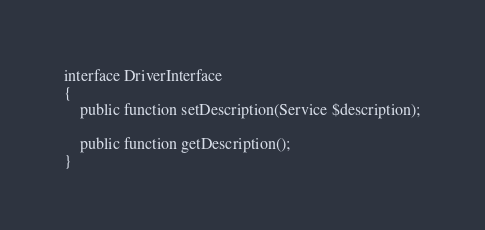Convert code to text. <code><loc_0><loc_0><loc_500><loc_500><_PHP_>
interface DriverInterface
{
    public function setDescription(Service $description);

    public function getDescription();
}
</code> 